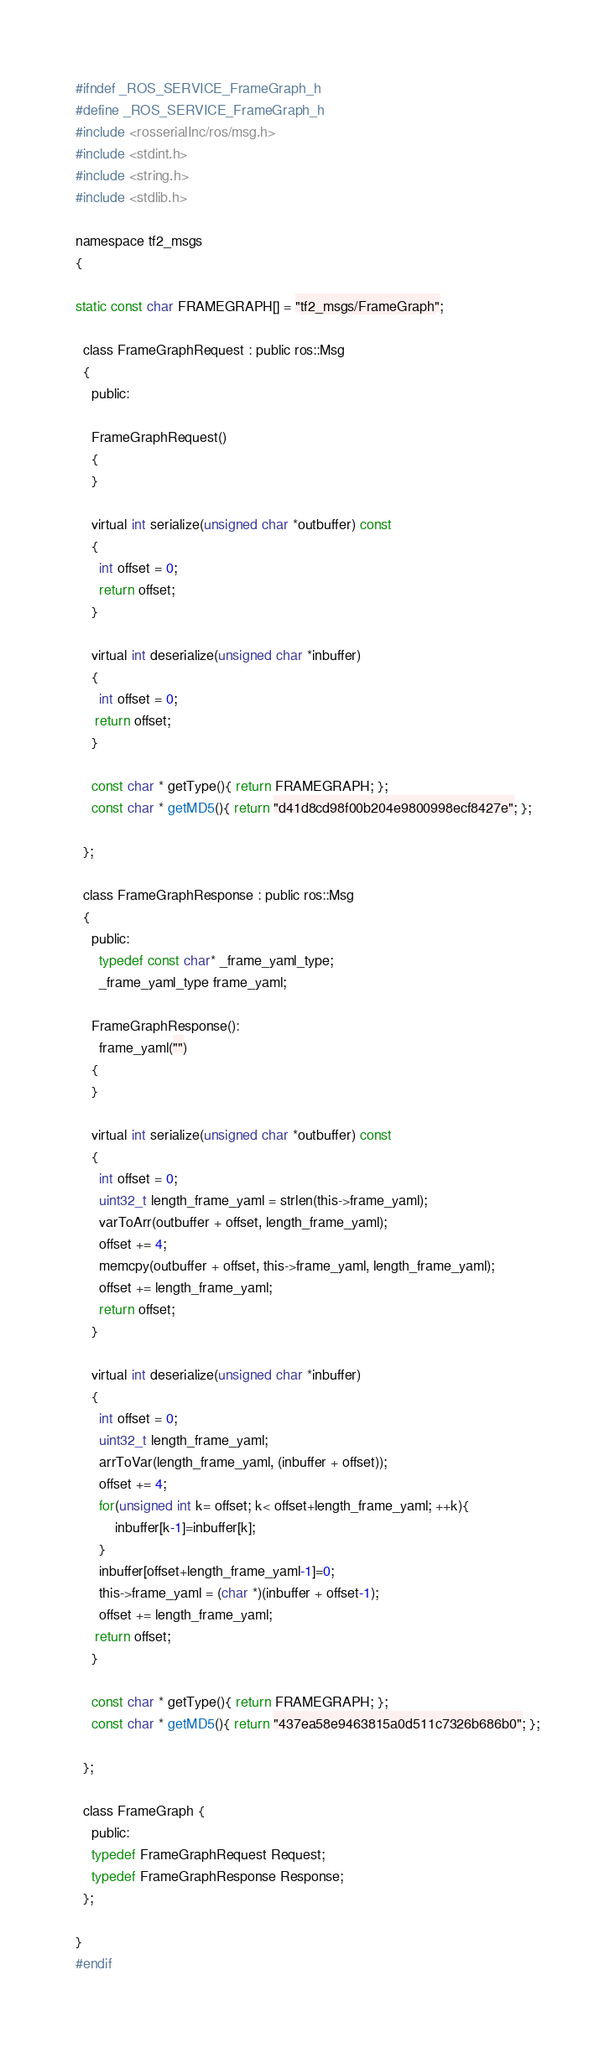Convert code to text. <code><loc_0><loc_0><loc_500><loc_500><_C_>#ifndef _ROS_SERVICE_FrameGraph_h
#define _ROS_SERVICE_FrameGraph_h
#include <rosserialInc/ros/msg.h>
#include <stdint.h>
#include <string.h>
#include <stdlib.h>

namespace tf2_msgs
{

static const char FRAMEGRAPH[] = "tf2_msgs/FrameGraph";

  class FrameGraphRequest : public ros::Msg
  {
    public:

    FrameGraphRequest()
    {
    }

    virtual int serialize(unsigned char *outbuffer) const
    {
      int offset = 0;
      return offset;
    }

    virtual int deserialize(unsigned char *inbuffer)
    {
      int offset = 0;
     return offset;
    }

    const char * getType(){ return FRAMEGRAPH; };
    const char * getMD5(){ return "d41d8cd98f00b204e9800998ecf8427e"; };

  };

  class FrameGraphResponse : public ros::Msg
  {
    public:
      typedef const char* _frame_yaml_type;
      _frame_yaml_type frame_yaml;

    FrameGraphResponse():
      frame_yaml("")
    {
    }

    virtual int serialize(unsigned char *outbuffer) const
    {
      int offset = 0;
      uint32_t length_frame_yaml = strlen(this->frame_yaml);
      varToArr(outbuffer + offset, length_frame_yaml);
      offset += 4;
      memcpy(outbuffer + offset, this->frame_yaml, length_frame_yaml);
      offset += length_frame_yaml;
      return offset;
    }

    virtual int deserialize(unsigned char *inbuffer)
    {
      int offset = 0;
      uint32_t length_frame_yaml;
      arrToVar(length_frame_yaml, (inbuffer + offset));
      offset += 4;
      for(unsigned int k= offset; k< offset+length_frame_yaml; ++k){
          inbuffer[k-1]=inbuffer[k];
      }
      inbuffer[offset+length_frame_yaml-1]=0;
      this->frame_yaml = (char *)(inbuffer + offset-1);
      offset += length_frame_yaml;
     return offset;
    }

    const char * getType(){ return FRAMEGRAPH; };
    const char * getMD5(){ return "437ea58e9463815a0d511c7326b686b0"; };

  };

  class FrameGraph {
    public:
    typedef FrameGraphRequest Request;
    typedef FrameGraphResponse Response;
  };

}
#endif
</code> 